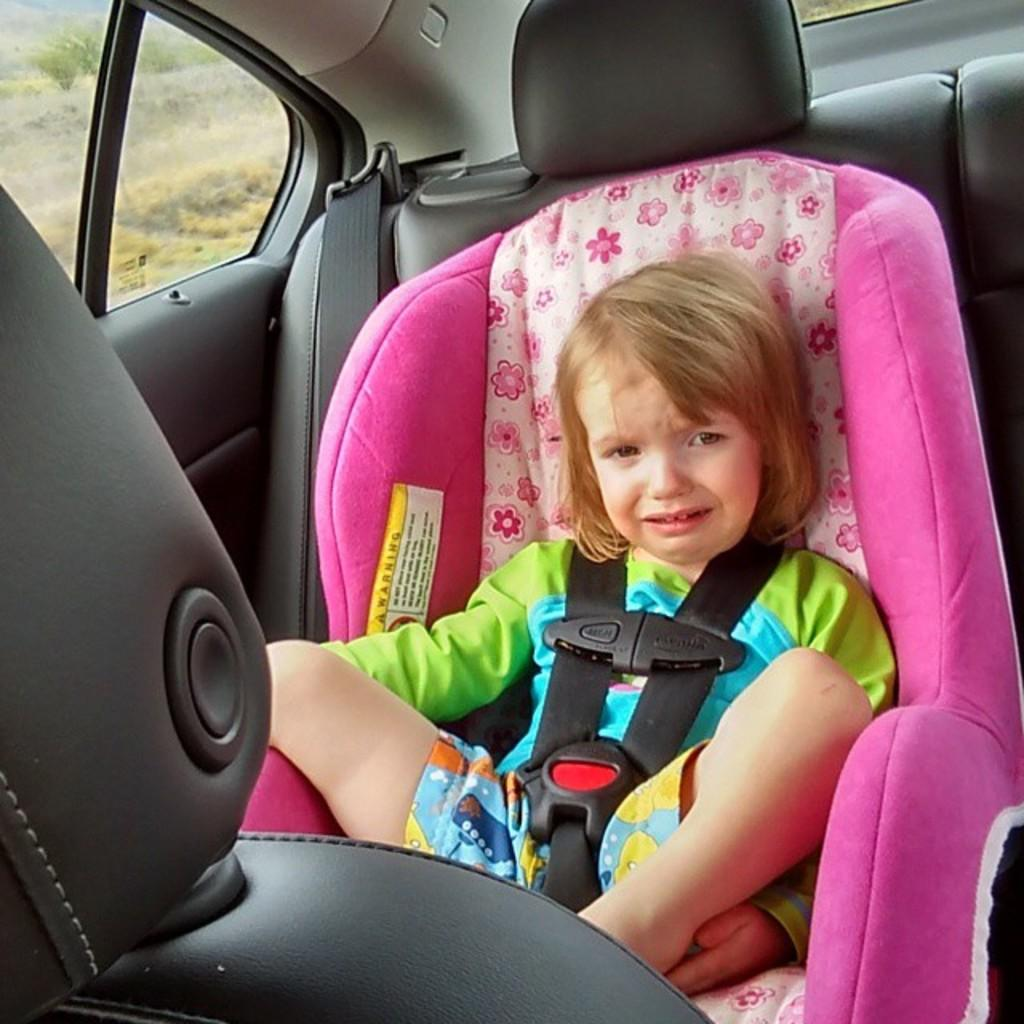What is the setting of the image? The image shows the inside view of a car. Who or what can be seen inside the car? There is a small girl in the car. How is the girl positioned in the car? The girl is sitting on a toddler. What is the emotional state of the girl? The girl is crying. What type of thunder can be heard in the image? There is no thunder present in the image, as it is an indoor scene inside a car. 